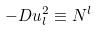Convert formula to latex. <formula><loc_0><loc_0><loc_500><loc_500>- D u _ { l } ^ { 2 } \equiv N ^ { l }</formula> 